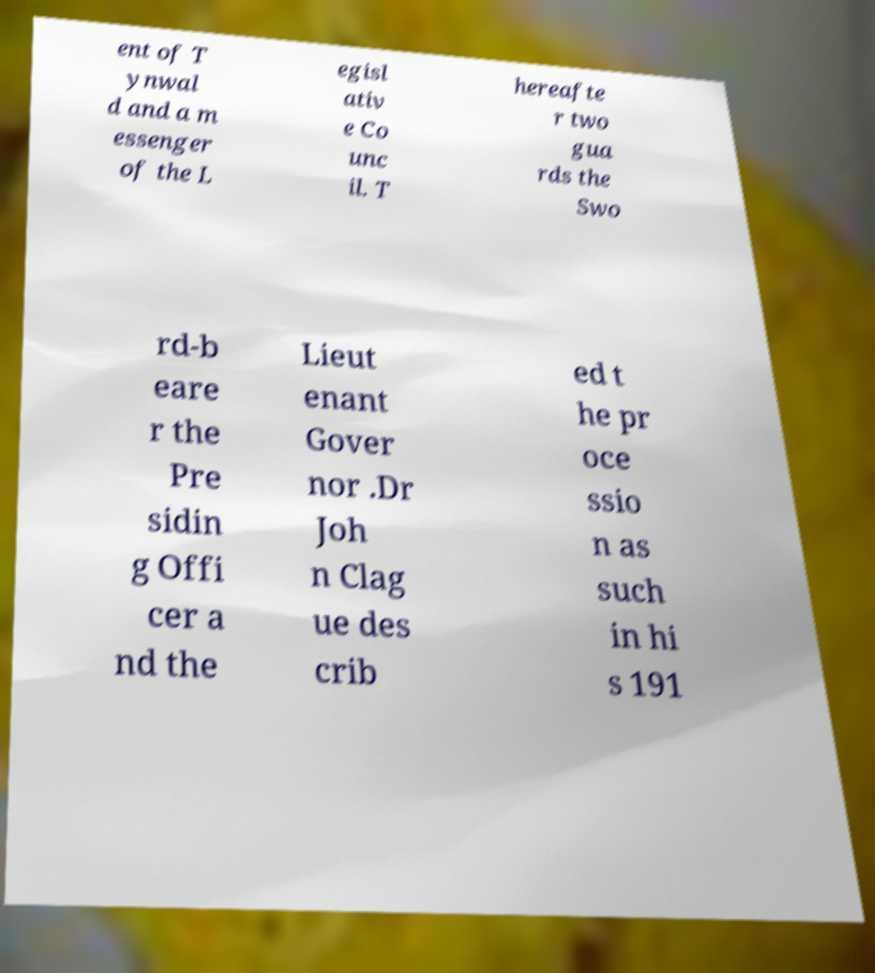For documentation purposes, I need the text within this image transcribed. Could you provide that? ent of T ynwal d and a m essenger of the L egisl ativ e Co unc il. T hereafte r two gua rds the Swo rd-b eare r the Pre sidin g Offi cer a nd the Lieut enant Gover nor .Dr Joh n Clag ue des crib ed t he pr oce ssio n as such in hi s 191 